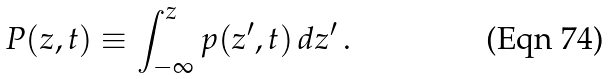Convert formula to latex. <formula><loc_0><loc_0><loc_500><loc_500>P ( z , t ) \equiv \int _ { - \infty } ^ { z } p ( z ^ { \prime } , t ) \, d z ^ { \prime } \, .</formula> 